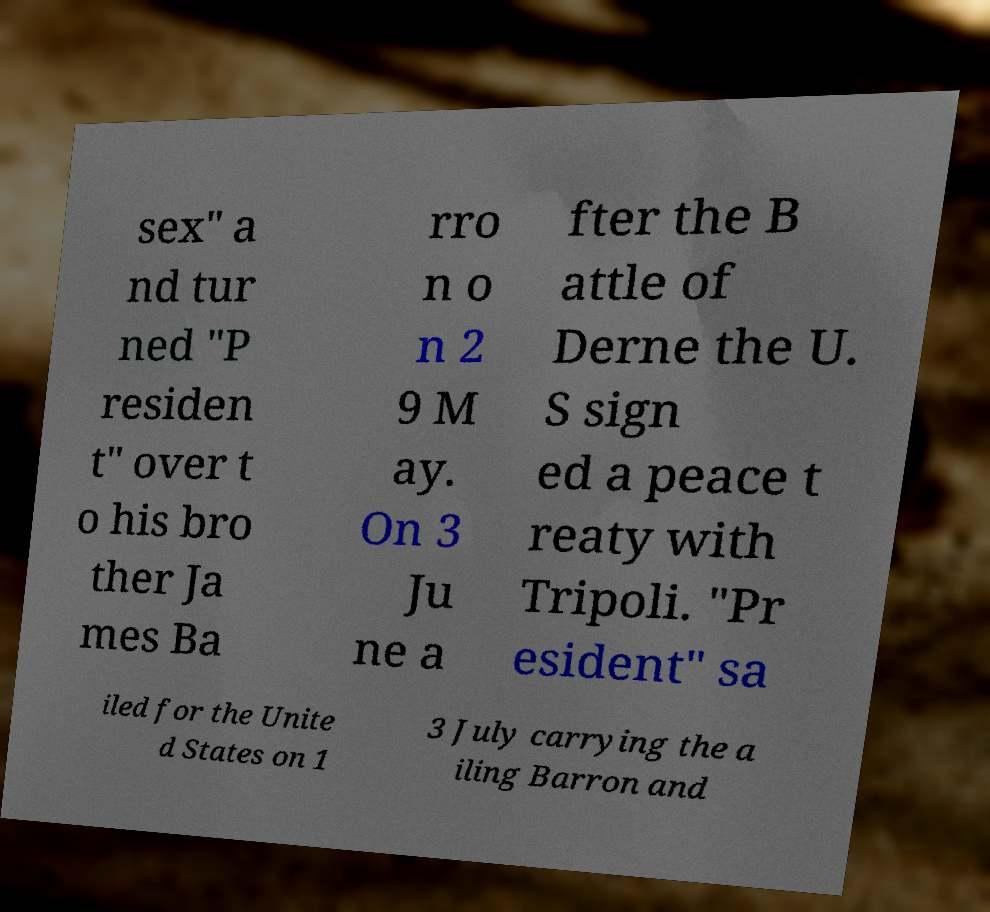Could you extract and type out the text from this image? sex" a nd tur ned "P residen t" over t o his bro ther Ja mes Ba rro n o n 2 9 M ay. On 3 Ju ne a fter the B attle of Derne the U. S sign ed a peace t reaty with Tripoli. "Pr esident" sa iled for the Unite d States on 1 3 July carrying the a iling Barron and 